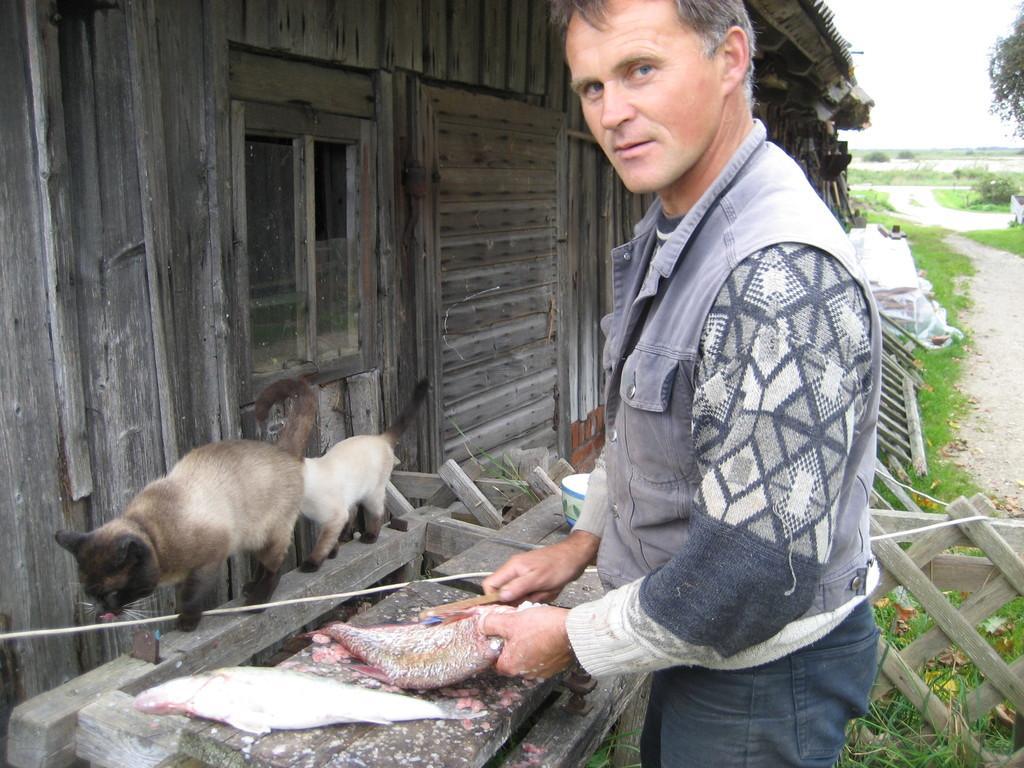How would you summarize this image in a sentence or two? In this image I can see a person holding a fish and I can see another fish kept on table and in the middle I can see a house and in front of the house I can see cats , on the right side I can see the sky and tree and grass. 